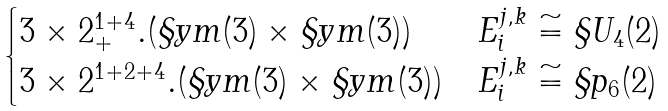Convert formula to latex. <formula><loc_0><loc_0><loc_500><loc_500>\begin{cases} 3 \times 2 ^ { 1 + 4 } _ { + } . ( \S y m ( 3 ) \times \S y m ( 3 ) ) & E _ { i } ^ { j , k } \cong \S U _ { 4 } ( 2 ) \\ 3 \times 2 ^ { 1 + 2 + 4 } . ( \S y m ( 3 ) \times \S y m ( 3 ) ) & E _ { i } ^ { j , k } \cong \S p _ { 6 } ( 2 ) \end{cases}</formula> 